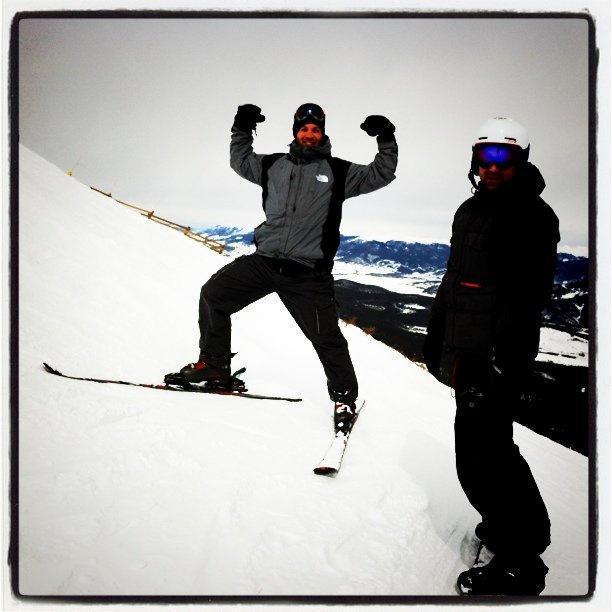How many people are there?
Give a very brief answer. 2. How many chairs are visible?
Give a very brief answer. 0. 